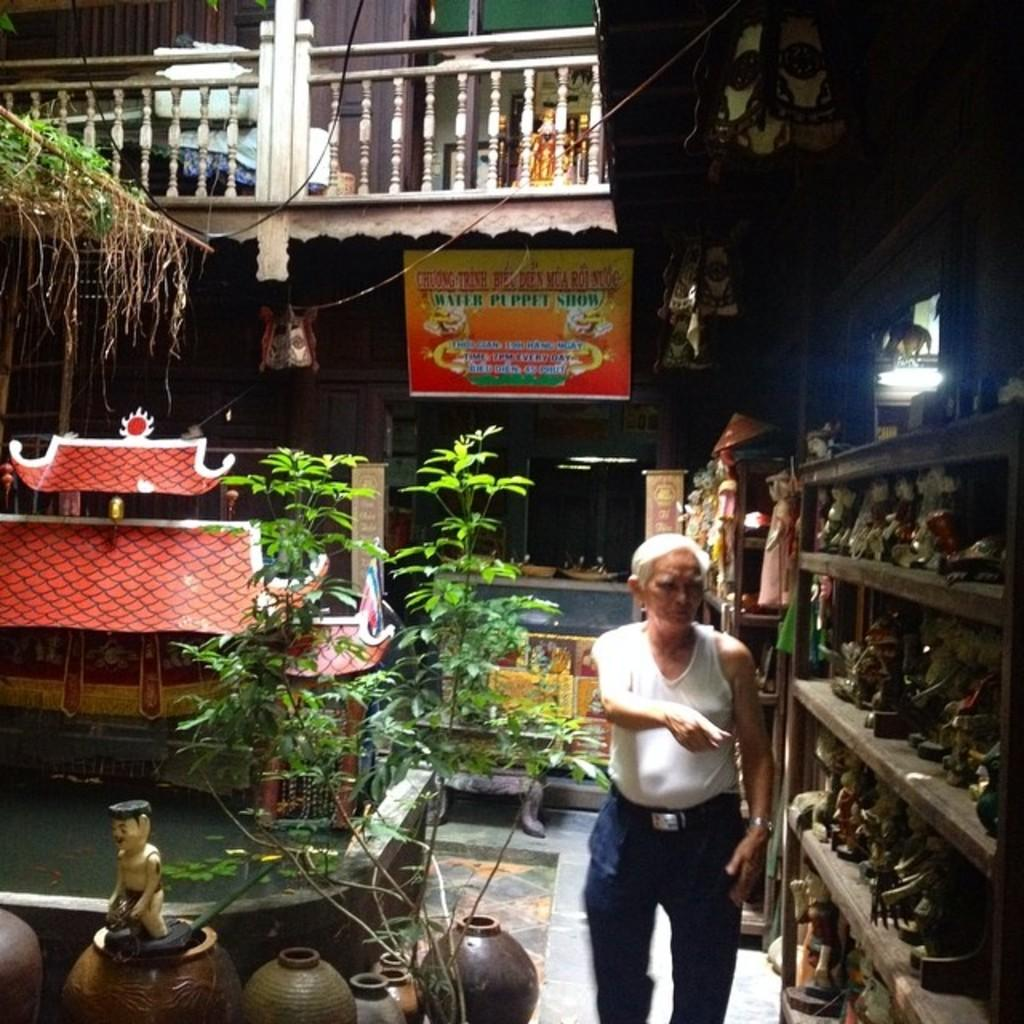What is the main subject of the image? There is an old person standing in the image. What is the old person doing in the image? The old person is pointing towards objects in the image. What type of objects can be seen in the image? There are plants and decorative objects in the image. What else can be seen in the image? There is a board and a wooden railing in the image. What type of smile can be seen on the base of the error in the image? There is no smile, base, or error present in the image. 